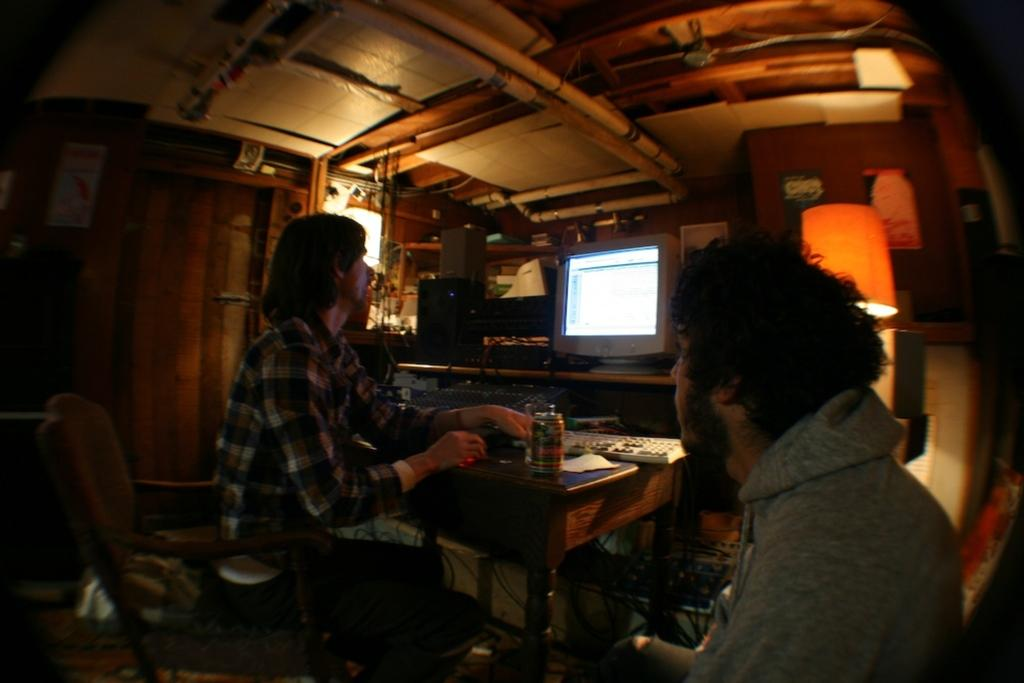How many people are sitting in the image? There are two persons sitting on chairs in the image. What is present on the table in the image? There is a monitor, a keyboard, and a tin on the table in the image. What can be seen in the background of the image? There is a door in the image. What type of tree can be seen outside the door in the image? There is no tree visible in the image; it only shows a door in the background. 